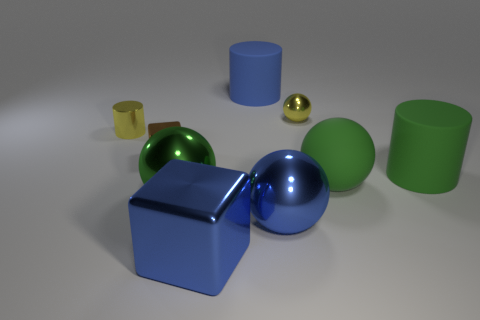What number of things are small metal objects or metal objects that are in front of the brown object?
Give a very brief answer. 6. Is the number of small metal objects that are left of the brown metallic block less than the number of objects behind the big green shiny sphere?
Make the answer very short. Yes. What number of other things are made of the same material as the large blue cylinder?
Offer a very short reply. 2. Does the big matte cylinder that is in front of the small cylinder have the same color as the large matte ball?
Give a very brief answer. Yes. There is a brown object behind the big green matte cylinder; are there any green cylinders that are behind it?
Provide a succinct answer. No. There is a big object that is in front of the tiny brown thing and behind the green matte sphere; what is it made of?
Your response must be concise. Rubber. There is a tiny yellow thing that is the same material as the tiny cylinder; what is its shape?
Offer a very short reply. Sphere. Is the material of the blue thing on the right side of the blue cylinder the same as the yellow sphere?
Make the answer very short. Yes. What is the sphere behind the big green matte cylinder made of?
Offer a terse response. Metal. There is a green rubber thing in front of the matte cylinder right of the small yellow metallic sphere; what size is it?
Keep it short and to the point. Large. 